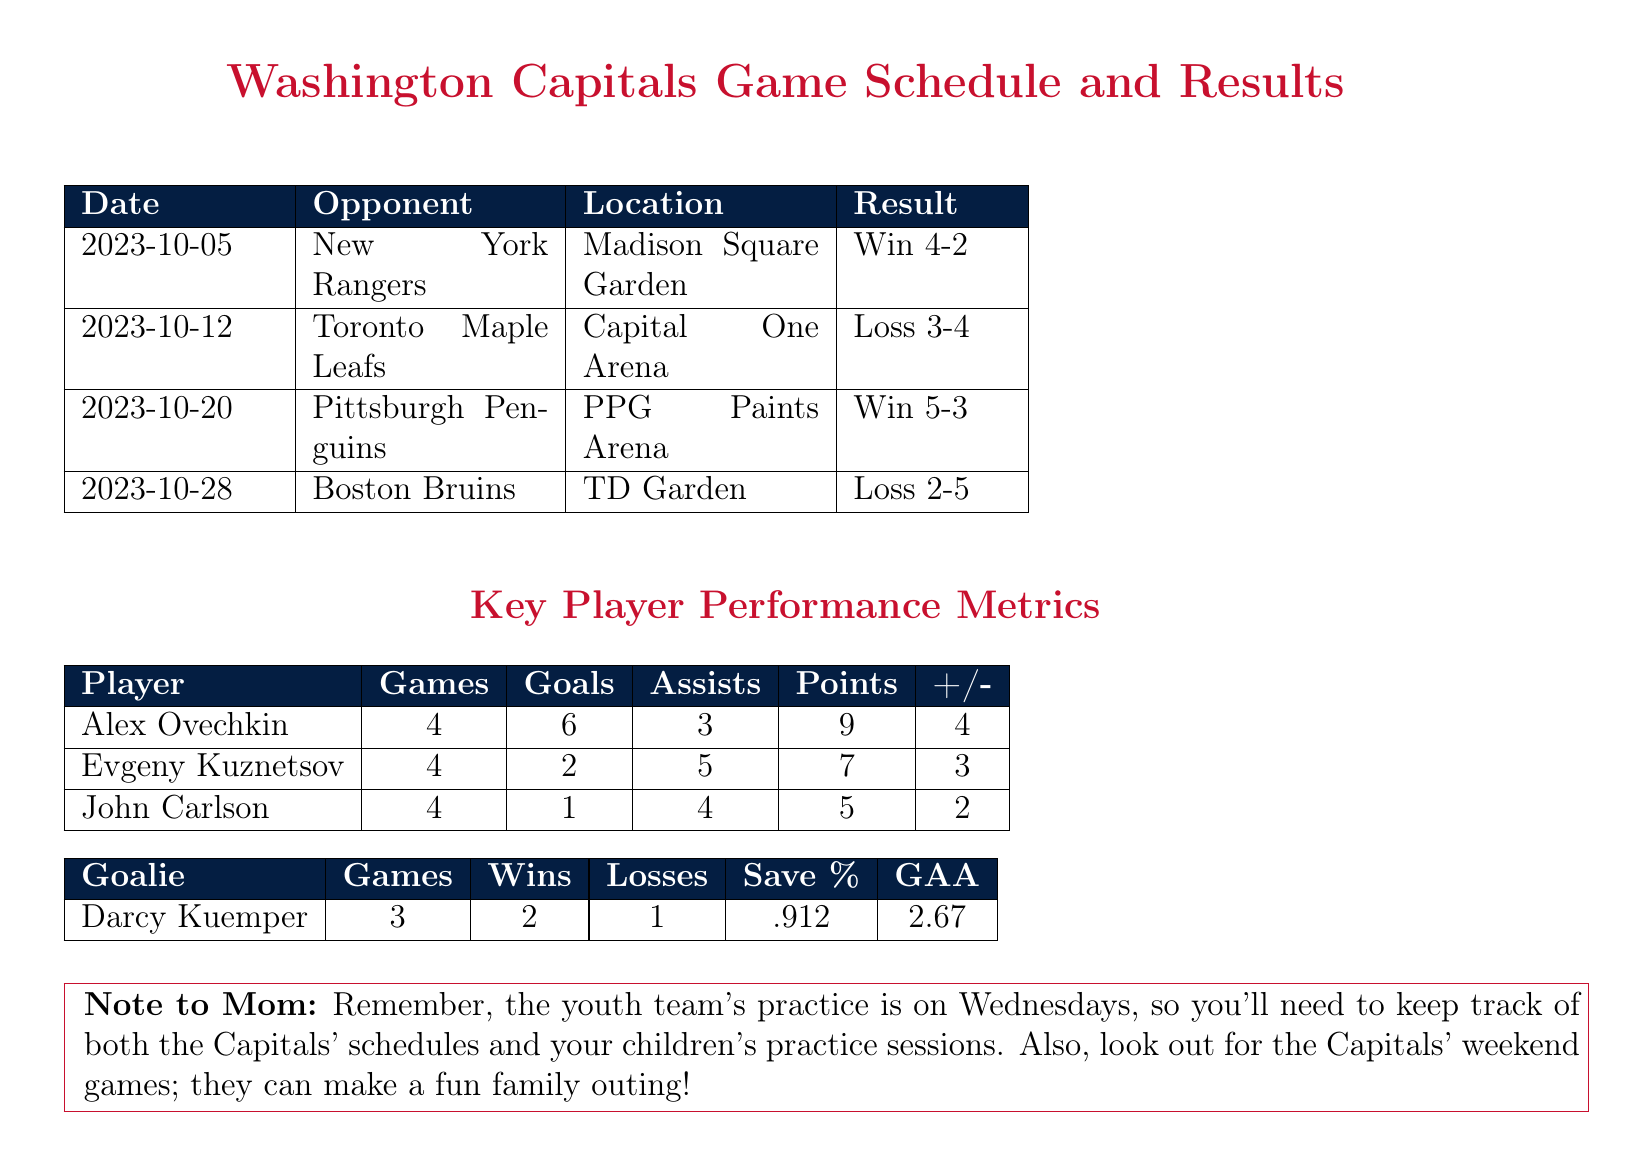What was the result of the game on October 12, 2023? The result of the game against the Toronto Maple Leafs was a loss, as stated in the schedule.
Answer: Loss 3-4 How many goals did Alex Ovechkin score? Alex Ovechkin scored a total of six goals in four games, as shown in the player performance metrics.
Answer: 6 Which player had the most points? Alex Ovechkin had the most points with nine, as indicated in the key player performance metrics.
Answer: 9 What is Darcy Kuemper's save percentage? The save percentage for goalie Darcy Kuemper is mentioned in the goalie statistics section.
Answer: .912 How many games did the Capitals win? The number of wins by the Capitals can be determined by counting the wins from the game results listed in the document.
Answer: 2 What was the date of the game against the Boston Bruins? The date is found in the game schedule, specifically referring to the matchup with the Boston Bruins.
Answer: 2023-10-28 How many assists did Evgeny Kuznetsov record? Evgeny Kuznetsov's assists are noted in the player metrics table.
Answer: 5 What was the outcome of the game against the Pittsburgh Penguins? The document provides detailed results for each game, including the game against the Pittsburgh Penguins.
Answer: Win 5-3 What is the GAA (Goals Against Average) for Darcy Kuemper? The GAA for goalie Darcy Kuemper is specified in the goalie performance metrics.
Answer: 2.67 